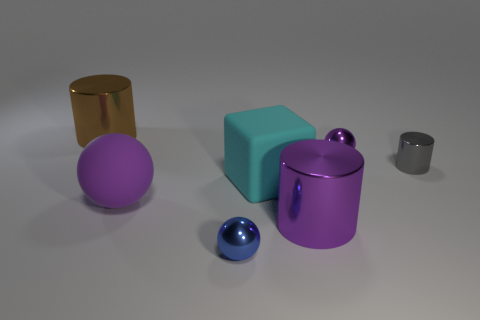Subtract all purple cylinders. How many cylinders are left? 2 Subtract all red cubes. How many purple spheres are left? 2 Add 2 tiny brown cylinders. How many objects exist? 9 Subtract all blocks. How many objects are left? 6 Subtract all green cylinders. Subtract all yellow blocks. How many cylinders are left? 3 Add 3 blocks. How many blocks exist? 4 Subtract 1 brown cylinders. How many objects are left? 6 Subtract all blue spheres. Subtract all matte objects. How many objects are left? 4 Add 5 balls. How many balls are left? 8 